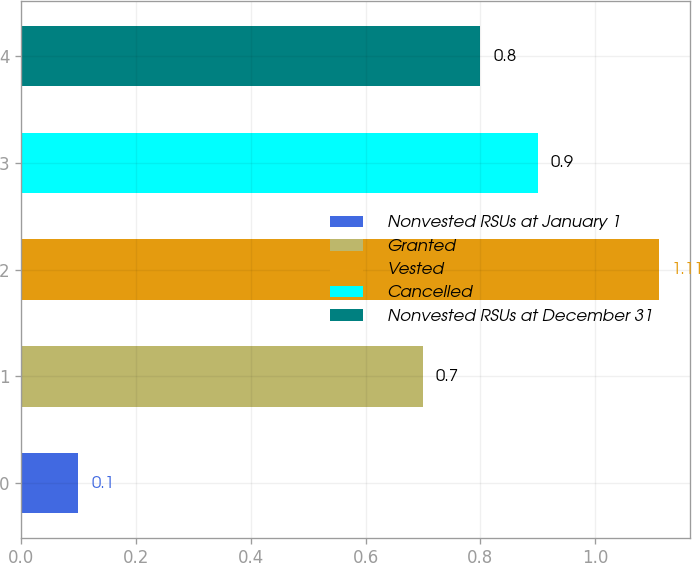Convert chart. <chart><loc_0><loc_0><loc_500><loc_500><bar_chart><fcel>Nonvested RSUs at January 1<fcel>Granted<fcel>Vested<fcel>Cancelled<fcel>Nonvested RSUs at December 31<nl><fcel>0.1<fcel>0.7<fcel>1.11<fcel>0.9<fcel>0.8<nl></chart> 